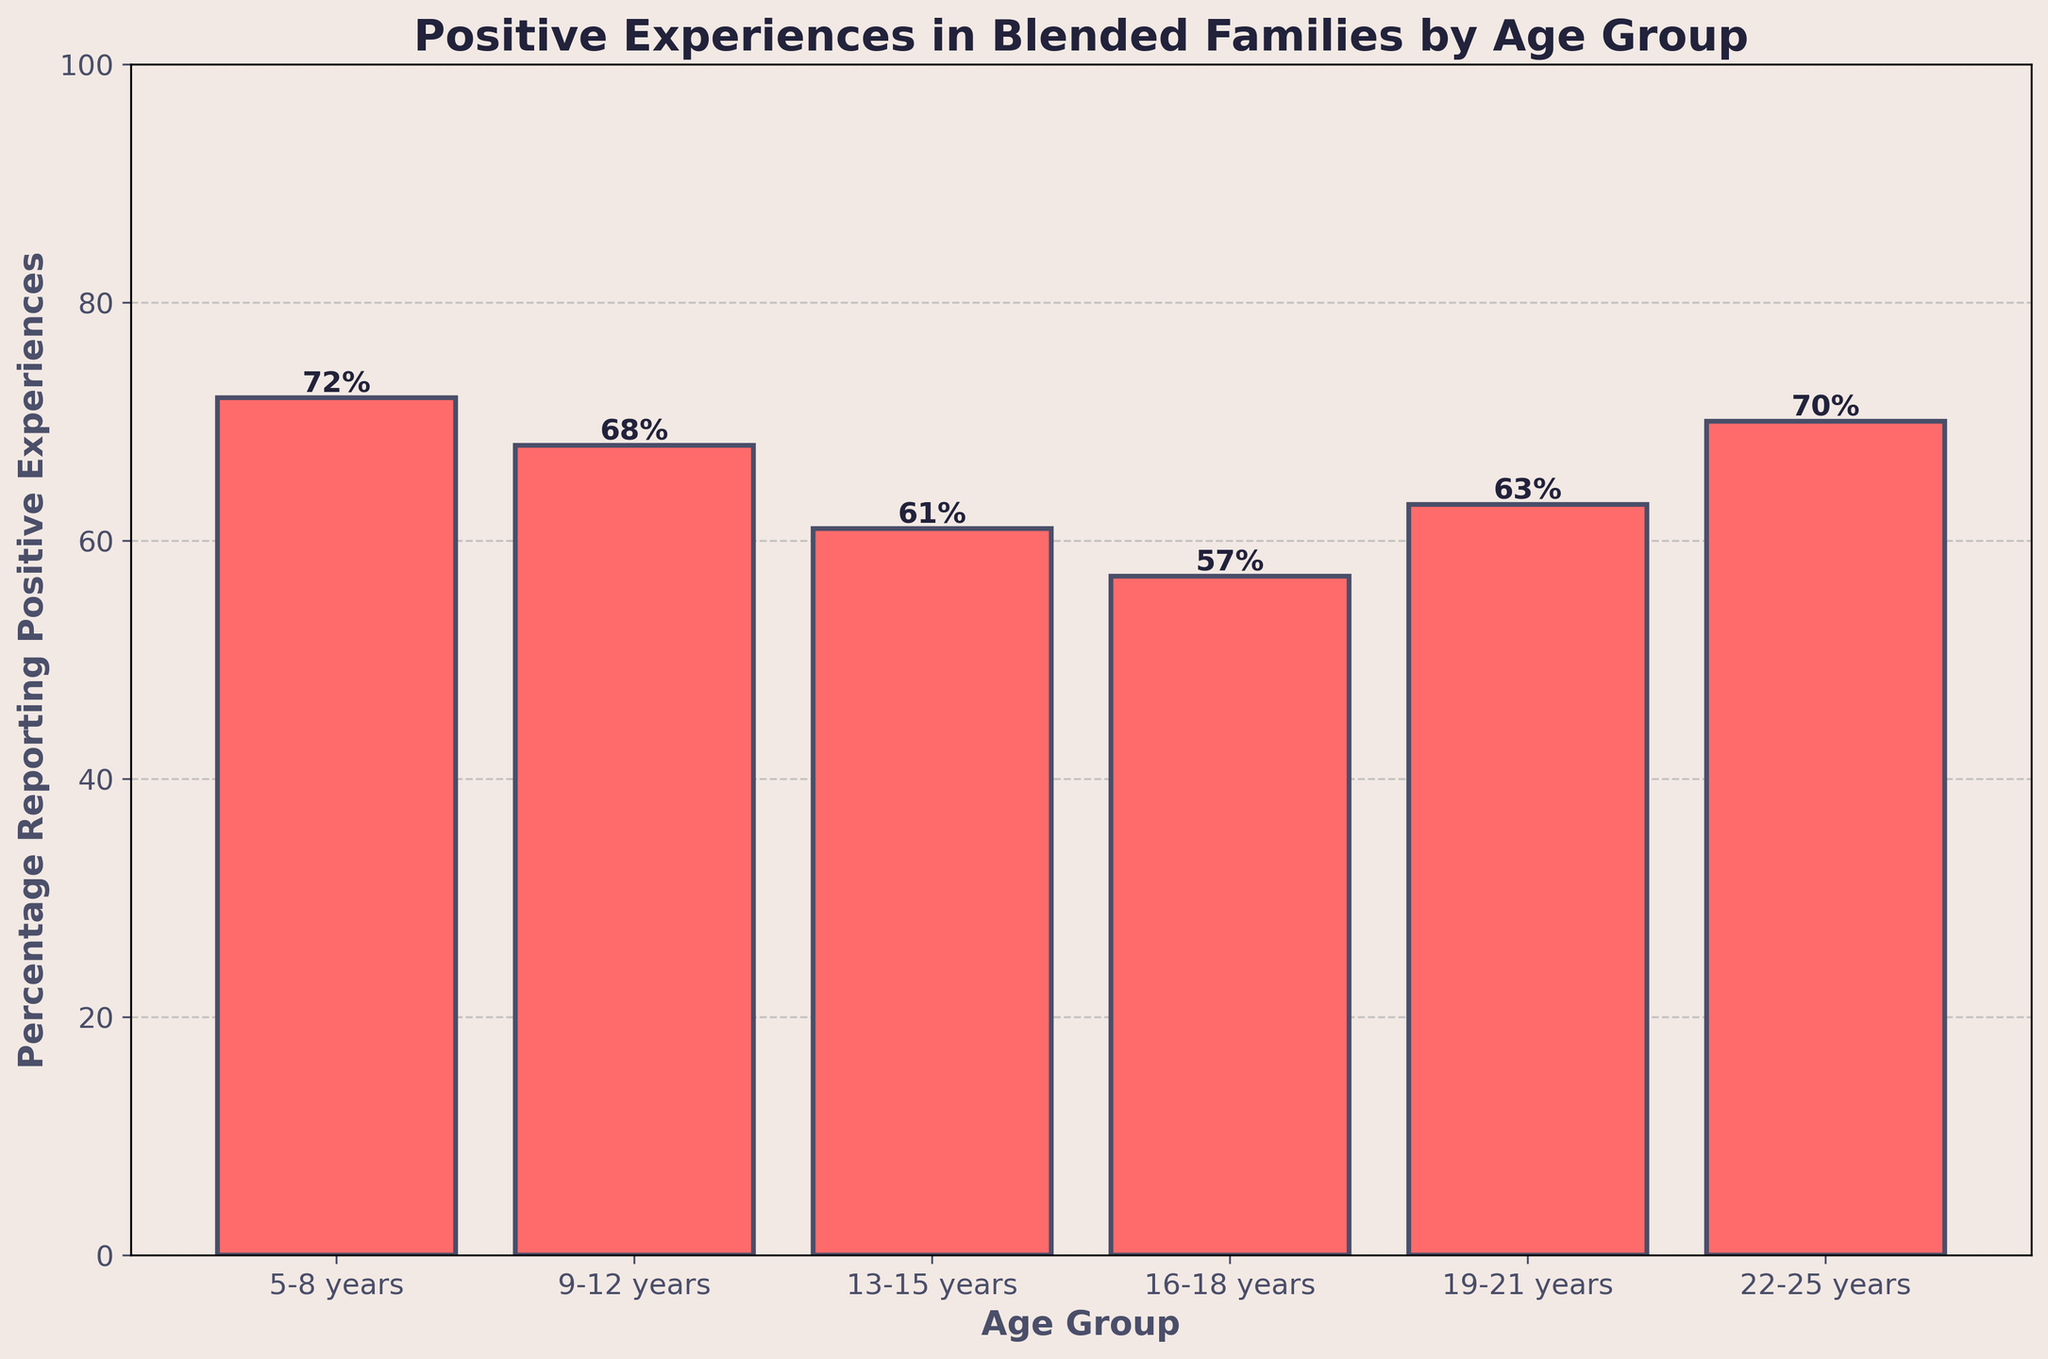What age group has the highest percentage reporting positive experiences? Looking at the heights of the bars, the age group "5-8 years" has the highest bar with a value of 72%.
Answer: 5-8 years What is the difference in percentage between the age group 13-15 years and 16-18 years? From the chart, the percentage for 13-15 years is 61%, and for 16-18 years, it is 57%. The difference is 61% - 57% = 4%.
Answer: 4% Which age groups have a higher percentage of positive experiences than the 13-15 years age group? The 13-15 years age group's percentage is 61%. The groups with higher percentages are 5-8 years (72%), 9-12 years (68%), 19-21 years (63%), and 22-25 years (70%).
Answer: 5-8 years, 9-12 years, 19-21 years, 22-25 years What is the average percentage of positive experiences for age groups ranging from 5 to 12 years old? The percentages for 5-8 and 9-12 years are 72% and 68%, respectively. The average is calculated as (72 + 68) / 2 = 70%.
Answer: 70% What percentage of positive experiences do the 22-25 years age group report, and how does it compare to the 16-18 years age group? The 22-25 years age group reports 70%, while the 16-18 years age group reports 57%. The percentage for 22-25 years is higher.
Answer: 70%, higher How many age groups have percentages of positive experiences below 60%? From the chart, only the 16-18 years age group has a percentage below 60% (57%).
Answer: 1 What is the average percentage of positive experiences reported for all the age groups combined? Sum all percentages: 72 + 68 + 61 + 57 + 63 + 70 = 391. There are 6 age groups, so the average is 391 / 6 ≈ 65%.
Answer: 65% Which age group shows the lowest percentage of positive experiences? By observing the chart, the "16-18 years" age group has the lowest bar at 57%.
Answer: 16-18 years How many age groups have percentages of positive experiences greater than 65%? The age groups 5-8 years (72%), 22-25 years (70%), and 9-12 years (68%) all have percentages greater than 65%.
Answer: 3 